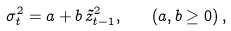<formula> <loc_0><loc_0><loc_500><loc_500>\sigma _ { t } ^ { 2 } = a + b \, \tilde { z } _ { t - 1 } ^ { 2 } , \quad \left ( a , b \geq 0 \right ) ,</formula> 